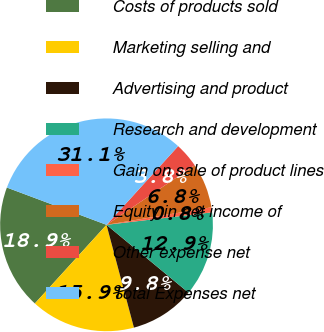Convert chart. <chart><loc_0><loc_0><loc_500><loc_500><pie_chart><fcel>Costs of products sold<fcel>Marketing selling and<fcel>Advertising and product<fcel>Research and development<fcel>Gain on sale of product lines<fcel>Equity in net income of<fcel>Other expense net<fcel>Total Expenses net<nl><fcel>18.94%<fcel>15.91%<fcel>9.85%<fcel>12.88%<fcel>0.76%<fcel>6.82%<fcel>3.79%<fcel>31.06%<nl></chart> 